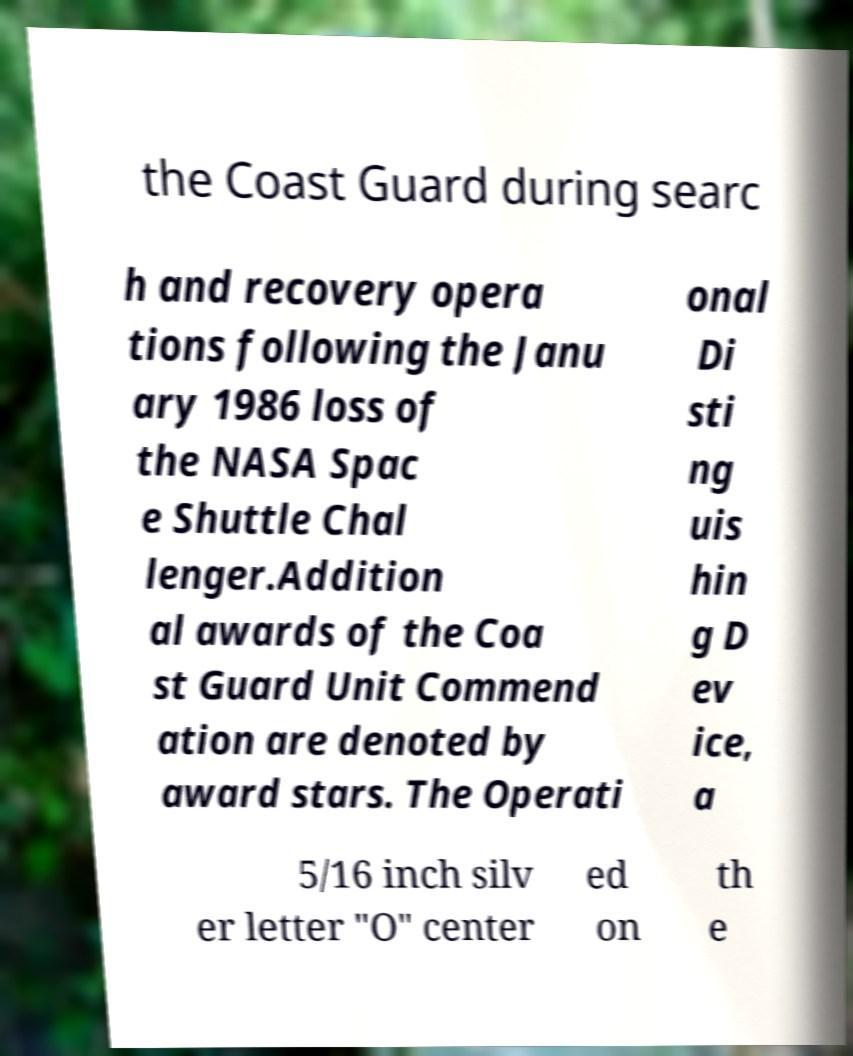Please identify and transcribe the text found in this image. the Coast Guard during searc h and recovery opera tions following the Janu ary 1986 loss of the NASA Spac e Shuttle Chal lenger.Addition al awards of the Coa st Guard Unit Commend ation are denoted by award stars. The Operati onal Di sti ng uis hin g D ev ice, a 5/16 inch silv er letter "O" center ed on th e 